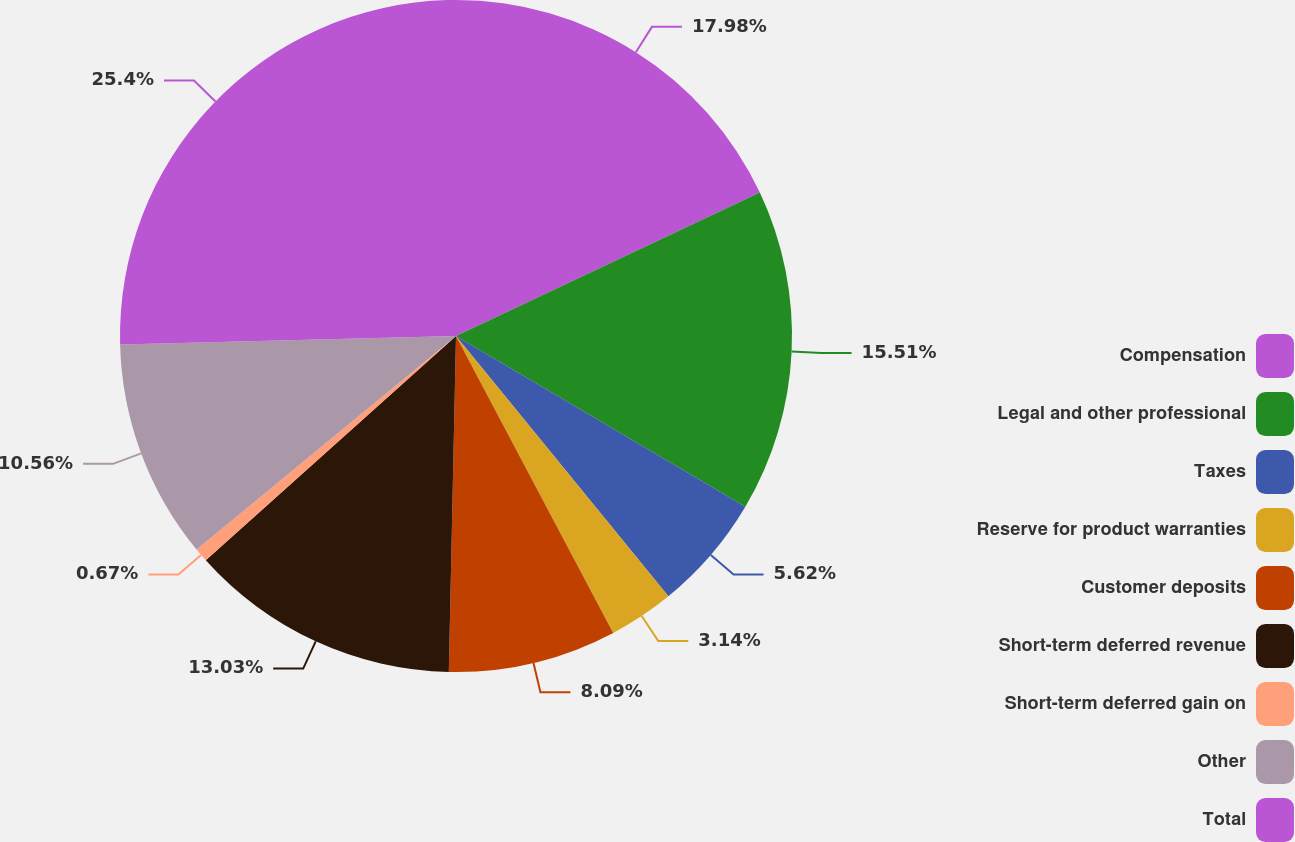<chart> <loc_0><loc_0><loc_500><loc_500><pie_chart><fcel>Compensation<fcel>Legal and other professional<fcel>Taxes<fcel>Reserve for product warranties<fcel>Customer deposits<fcel>Short-term deferred revenue<fcel>Short-term deferred gain on<fcel>Other<fcel>Total<nl><fcel>17.98%<fcel>15.51%<fcel>5.62%<fcel>3.14%<fcel>8.09%<fcel>13.03%<fcel>0.67%<fcel>10.56%<fcel>25.4%<nl></chart> 